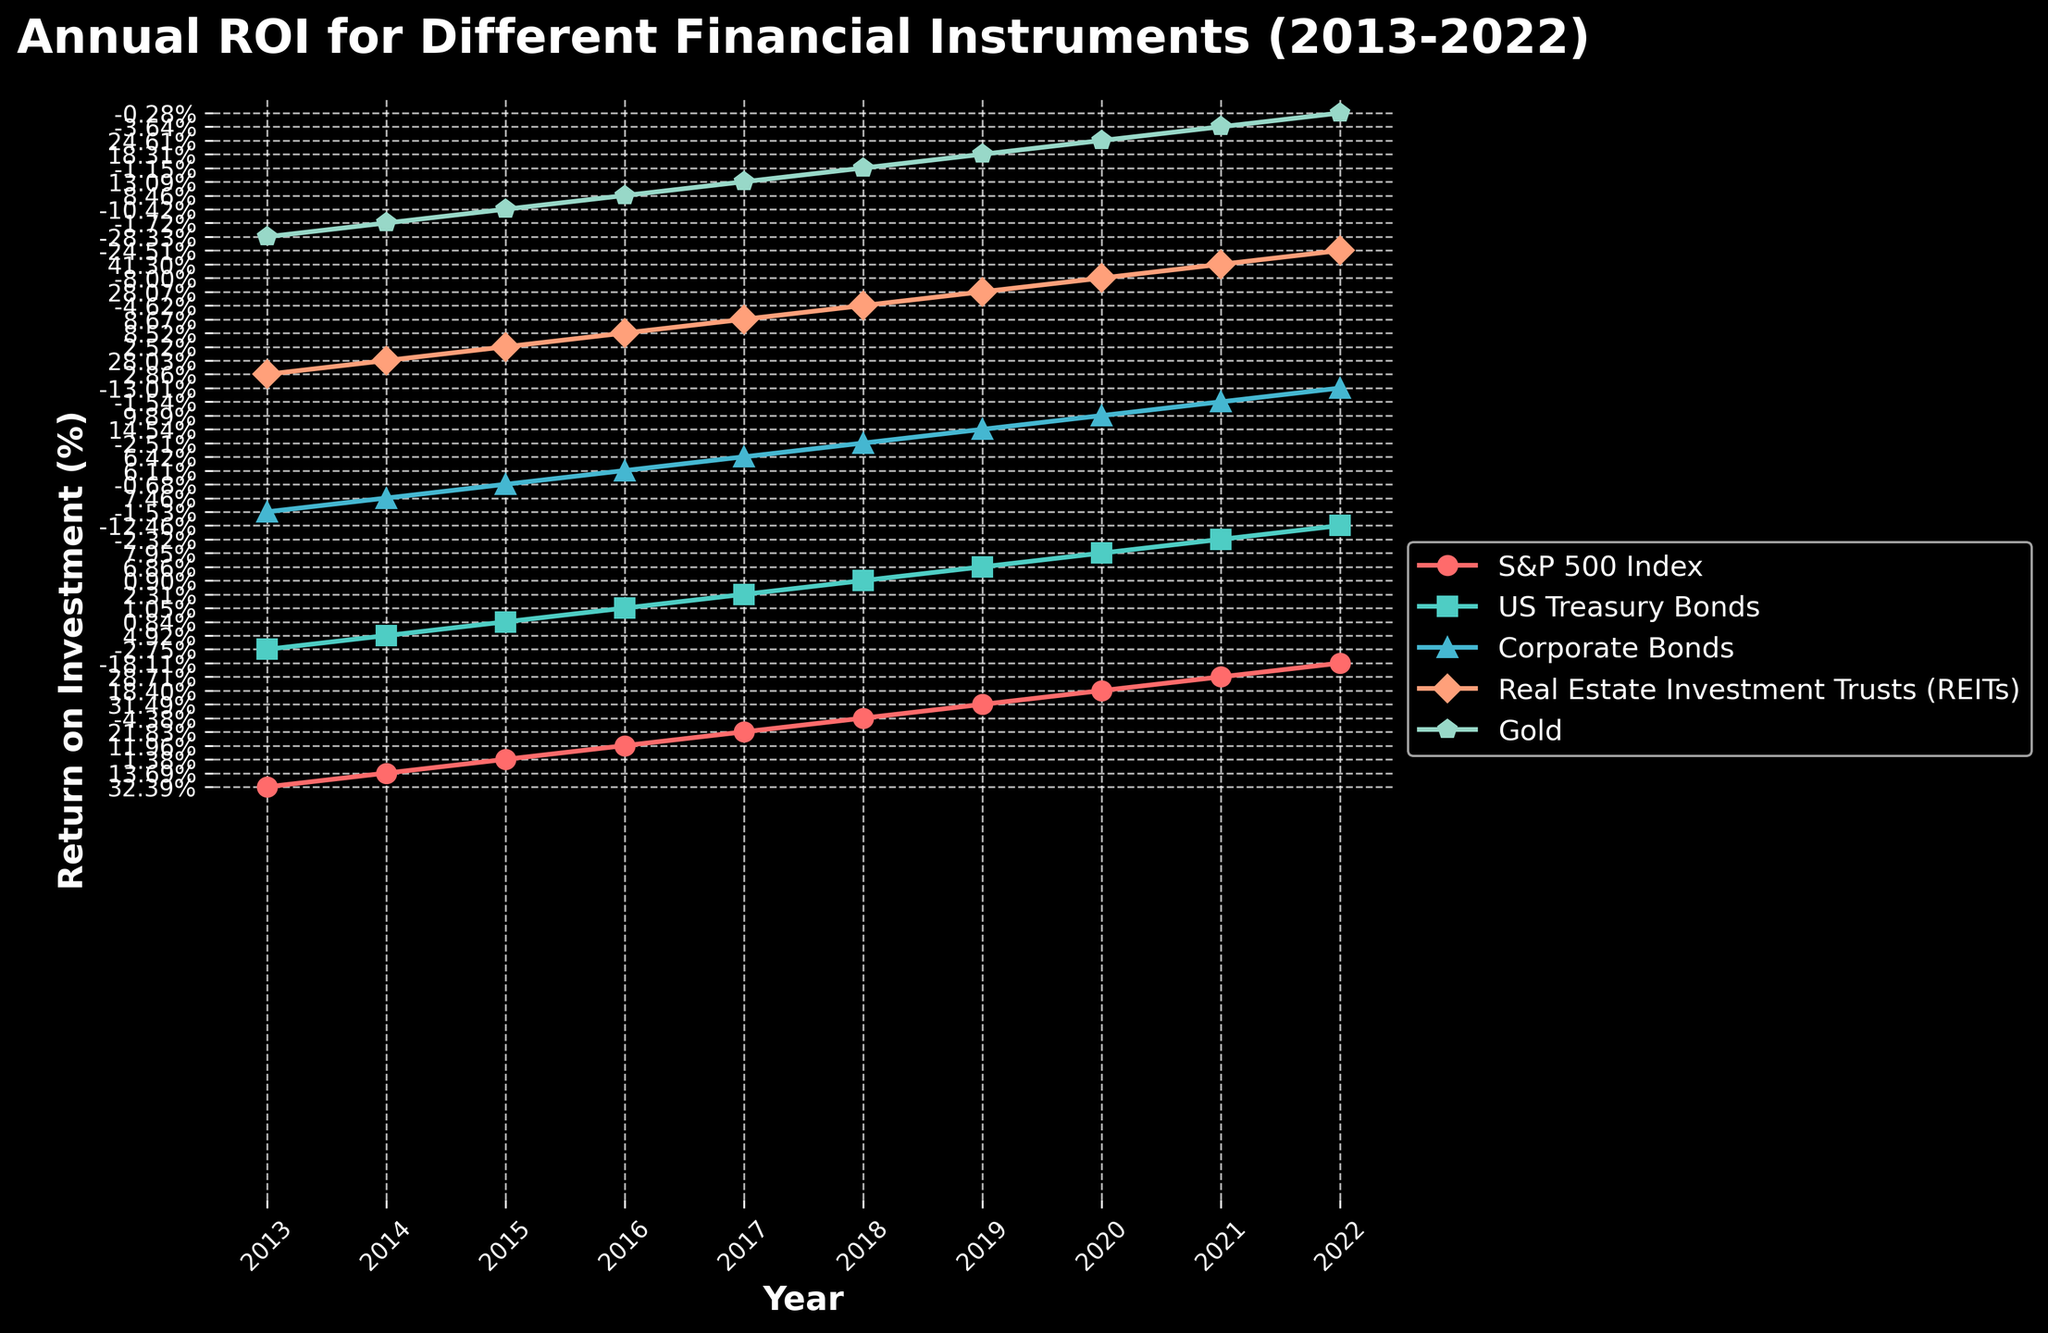Which financial instrument had the highest ROI in 2019? Looking at the data points for the year 2019, the highest ROI can be observed from the plot where the line reaches the maximum height for that specific year. The Real Estate Investment Trusts (REITs) line reaches the highest point in 2019.
Answer: Real Estate Investment Trusts (REITs) How did the ROI of US Treasury Bonds change from 2020 to 2021? Examine the US Treasury Bonds line between the points corresponding to the years 2020 and 2021. The ROI decreased from 7.95% in 2020 to -2.32% in 2021.
Answer: Decreased Compare the ROI trends of S&P 500 Index and Gold over the 10 years. Which one had more consistent returns? Review the general trajectory of both the S&P 500 Index and Gold lines over the 10 years. The S&P 500 Index shows relatively steady upward trends and occasional dips, whereas Gold exhibits more fluctuations in ROI.
Answer: S&P 500 Index In what year did Corporate Bonds have a negative ROI? Look at the data points for Corporate Bonds across the years. Negative ROI values can be identified where the line dips below zero. Corporate Bonds had negative ROI in 2013, 2015, 2018, and 2022.
Answer: 2013, 2015, 2018, 2022 Calculate the average ROI for Real Estate Investment Trusts (REITs) from 2014 to 2019. Sum up the ROIs for REITs from the years 2014 to 2019 and divide by the number of years (6). The ROI values are 28.03%, 2.52%, 8.52%, 8.67%, -4.62%, and 28.07%. The sum is 70.19%, and the average is 70.19/6.
Answer: 11.70% Which year had the highest average ROI across all financial instruments? Compute the average ROI for each year by summing the ROI values of each financial instrument for that year and dividing by the number of instruments (5). Compare these averages across all years. 2019 has the highest average ROI.
Answer: 2019 What was the difference in ROI between S&P 500 Index and Corporate Bonds in 2016? Look at the ROI values for S&P 500 Index (11.96%) and Corporate Bonds (6.11%) in 2016. The difference is 11.96% - 6.11%.
Answer: 5.85% Identify the financial instrument with the most volatile ROI over the period. Volatility can be assessed by examining the consistency and magnitude of changes in the ROI for each financial instrument. Gold's ROI shows significant fluctuations, indicating it is the most volatile.
Answer: Gold In 2022, which financial instrument had the least negative ROI? Inspect the 2022 data points for all financial instruments and identify which one has the value closest to zero. Gold had the least negative ROI at -0.28%.
Answer: Gold 